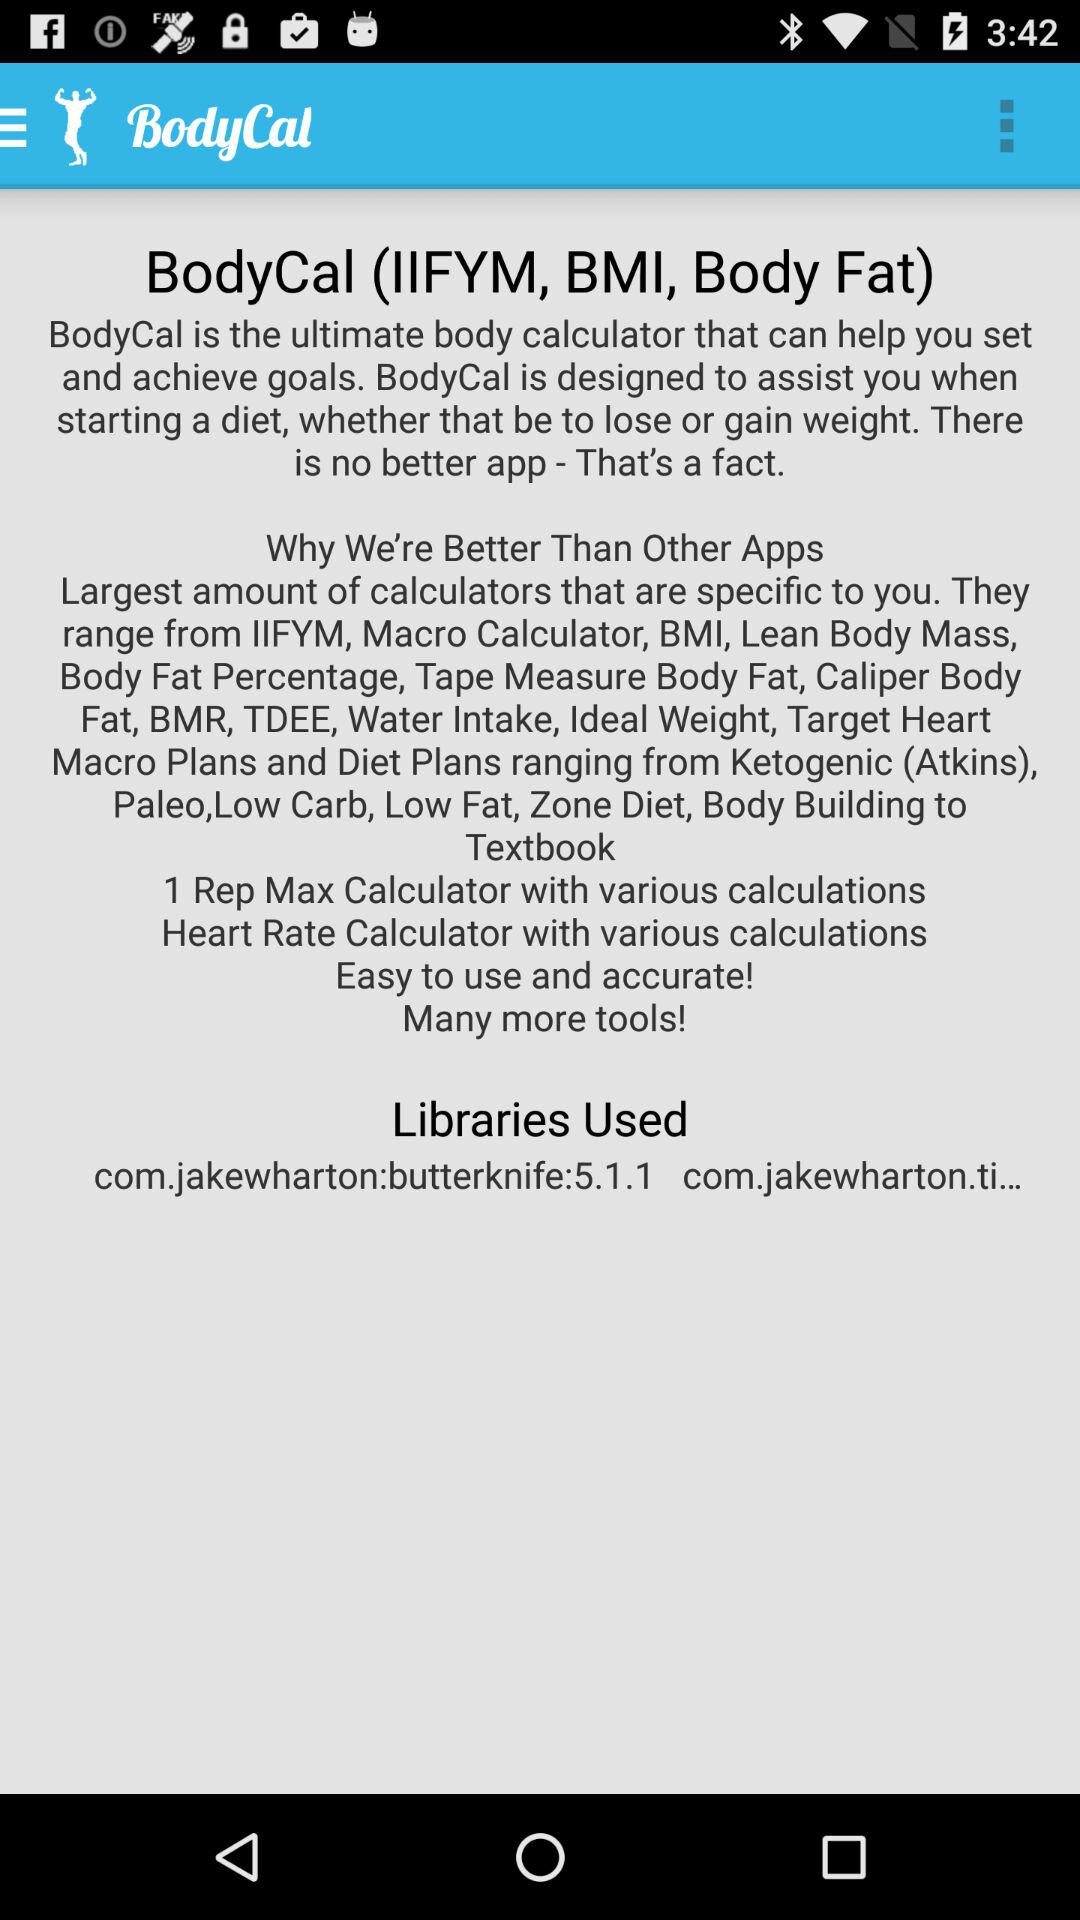How many libraries are used by BodyCal?
Answer the question using a single word or phrase. 2 